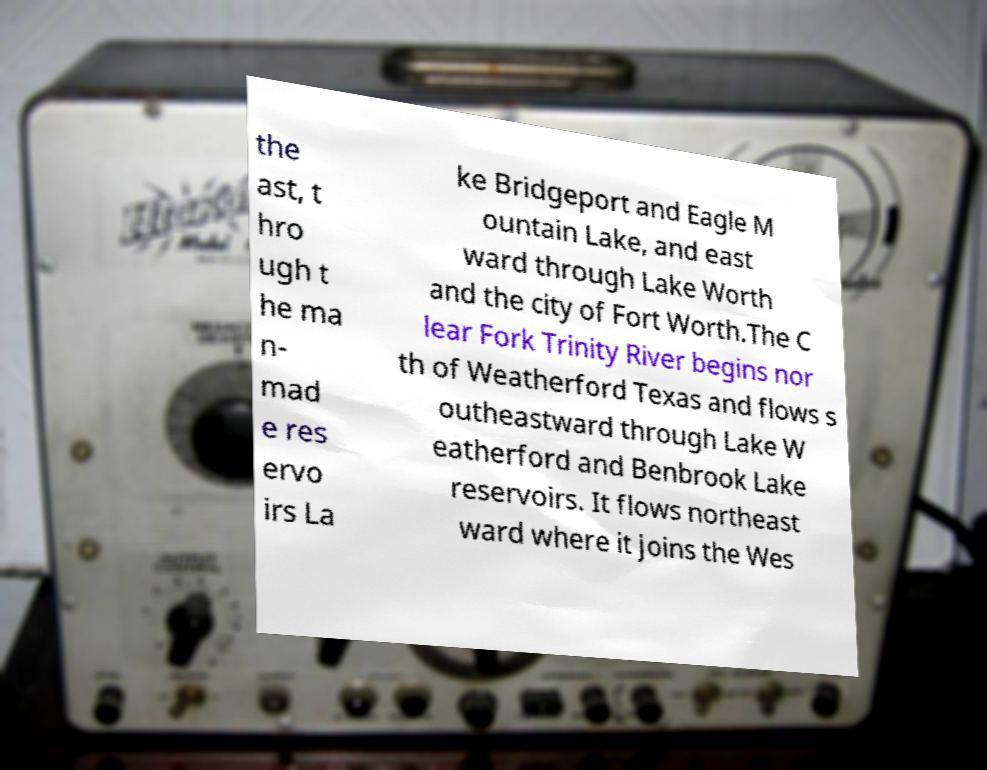Could you assist in decoding the text presented in this image and type it out clearly? the ast, t hro ugh t he ma n- mad e res ervo irs La ke Bridgeport and Eagle M ountain Lake, and east ward through Lake Worth and the city of Fort Worth.The C lear Fork Trinity River begins nor th of Weatherford Texas and flows s outheastward through Lake W eatherford and Benbrook Lake reservoirs. It flows northeast ward where it joins the Wes 